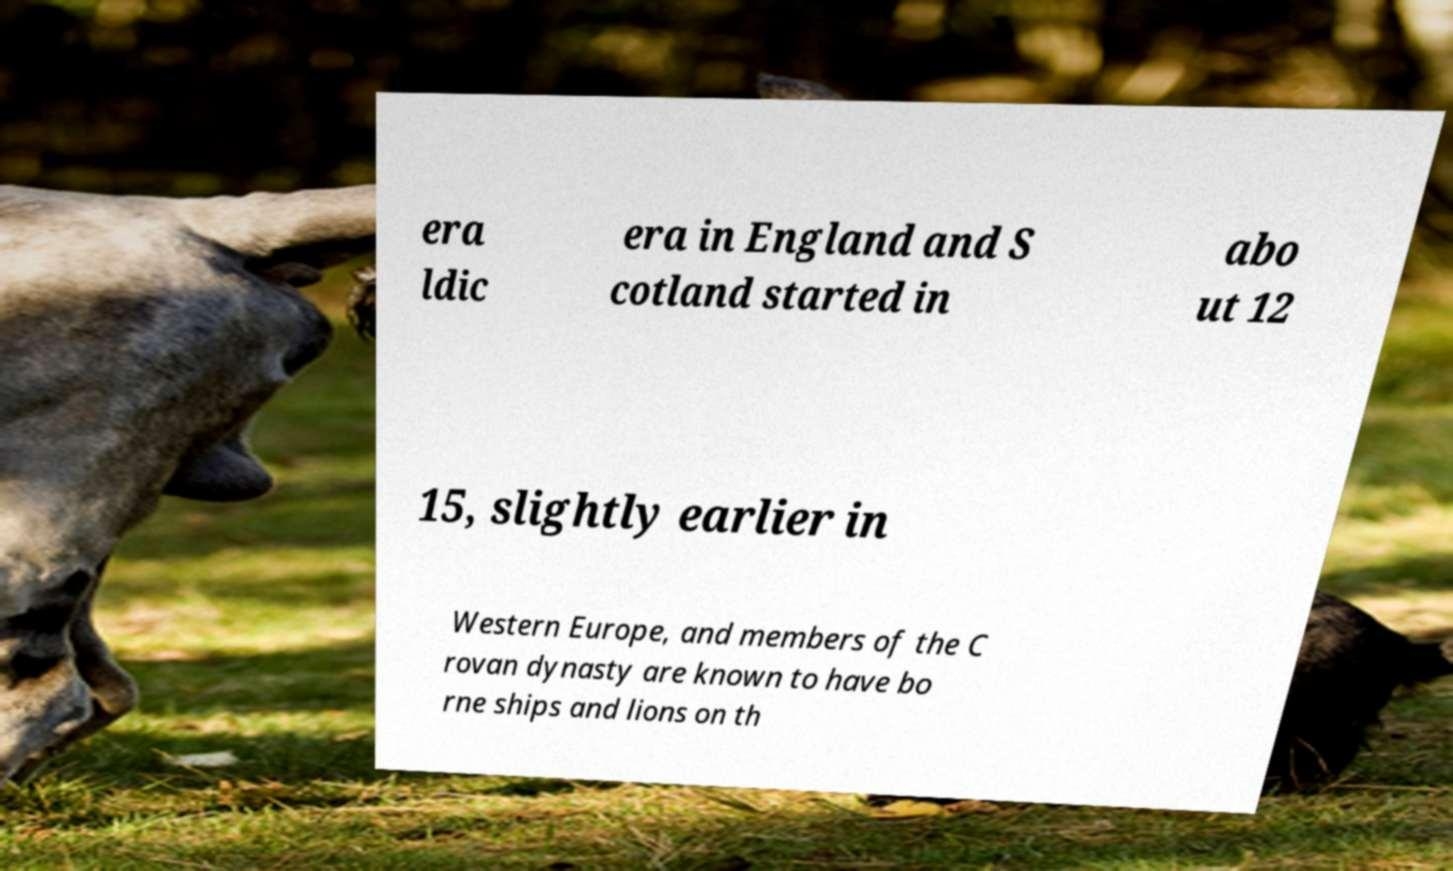I need the written content from this picture converted into text. Can you do that? era ldic era in England and S cotland started in abo ut 12 15, slightly earlier in Western Europe, and members of the C rovan dynasty are known to have bo rne ships and lions on th 